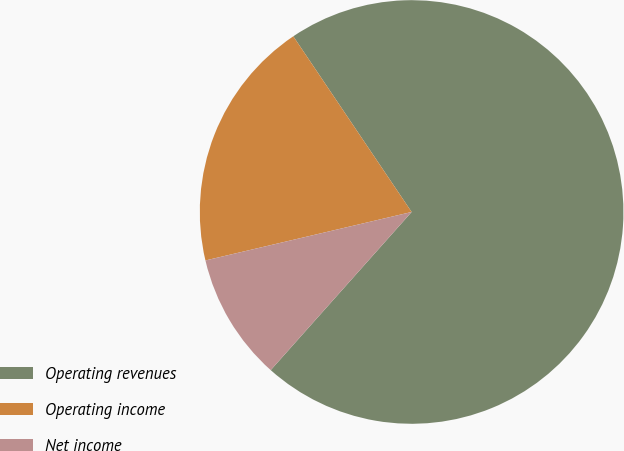Convert chart. <chart><loc_0><loc_0><loc_500><loc_500><pie_chart><fcel>Operating revenues<fcel>Operating income<fcel>Net income<nl><fcel>71.02%<fcel>19.24%<fcel>9.74%<nl></chart> 